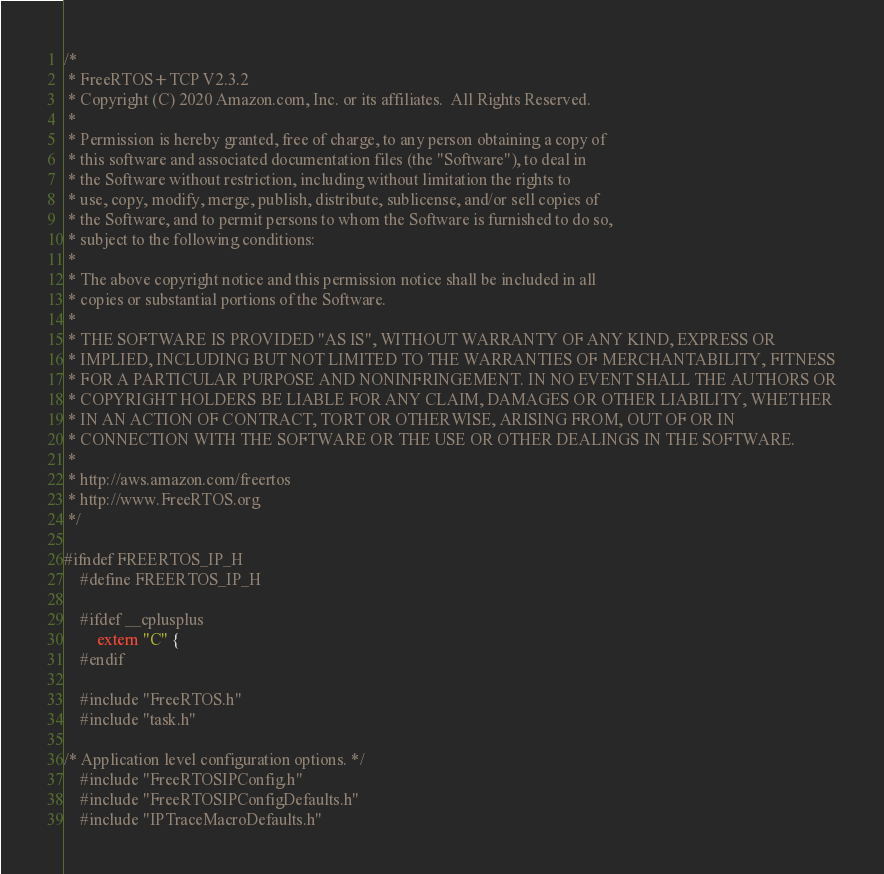Convert code to text. <code><loc_0><loc_0><loc_500><loc_500><_C_>/*
 * FreeRTOS+TCP V2.3.2
 * Copyright (C) 2020 Amazon.com, Inc. or its affiliates.  All Rights Reserved.
 *
 * Permission is hereby granted, free of charge, to any person obtaining a copy of
 * this software and associated documentation files (the "Software"), to deal in
 * the Software without restriction, including without limitation the rights to
 * use, copy, modify, merge, publish, distribute, sublicense, and/or sell copies of
 * the Software, and to permit persons to whom the Software is furnished to do so,
 * subject to the following conditions:
 *
 * The above copyright notice and this permission notice shall be included in all
 * copies or substantial portions of the Software.
 *
 * THE SOFTWARE IS PROVIDED "AS IS", WITHOUT WARRANTY OF ANY KIND, EXPRESS OR
 * IMPLIED, INCLUDING BUT NOT LIMITED TO THE WARRANTIES OF MERCHANTABILITY, FITNESS
 * FOR A PARTICULAR PURPOSE AND NONINFRINGEMENT. IN NO EVENT SHALL THE AUTHORS OR
 * COPYRIGHT HOLDERS BE LIABLE FOR ANY CLAIM, DAMAGES OR OTHER LIABILITY, WHETHER
 * IN AN ACTION OF CONTRACT, TORT OR OTHERWISE, ARISING FROM, OUT OF OR IN
 * CONNECTION WITH THE SOFTWARE OR THE USE OR OTHER DEALINGS IN THE SOFTWARE.
 *
 * http://aws.amazon.com/freertos
 * http://www.FreeRTOS.org
 */

#ifndef FREERTOS_IP_H
    #define FREERTOS_IP_H

    #ifdef __cplusplus
        extern "C" {
    #endif

    #include "FreeRTOS.h"
    #include "task.h"

/* Application level configuration options. */
    #include "FreeRTOSIPConfig.h"
    #include "FreeRTOSIPConfigDefaults.h"
    #include "IPTraceMacroDefaults.h"
</code> 